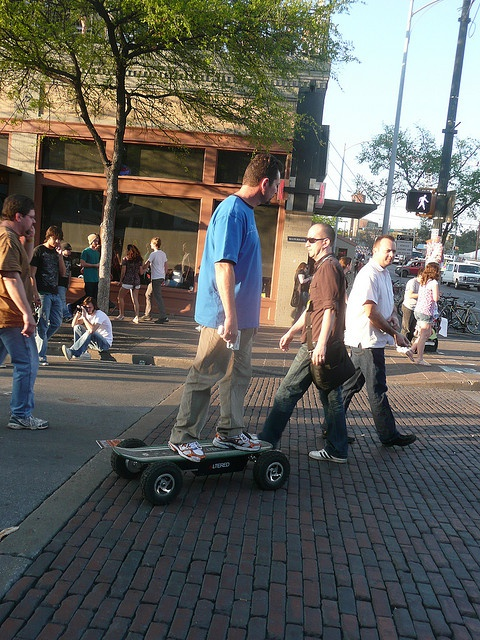Describe the objects in this image and their specific colors. I can see people in darkgreen, gray, lightblue, black, and blue tones, people in darkgreen, black, gray, and beige tones, people in darkgreen, white, black, gray, and darkgray tones, people in darkgreen, black, maroon, gray, and navy tones, and skateboard in darkgreen, black, gray, purple, and darkgray tones in this image. 